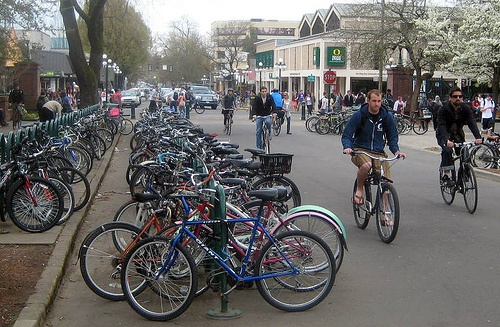Describe the objects in this image and their specific colors. I can see bicycle in gray, black, and darkgray tones, bicycle in gray, black, navy, and darkgray tones, people in gray, black, and darkgray tones, bicycle in gray, black, and darkgray tones, and bicycle in gray, black, darkgray, and purple tones in this image. 